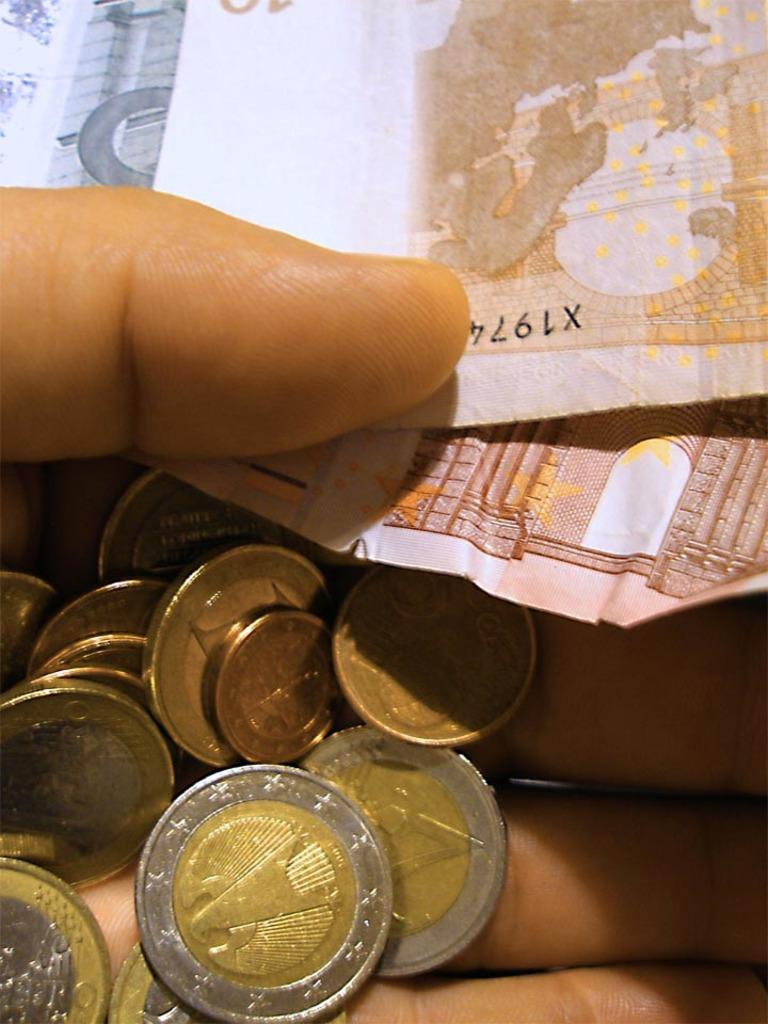<image>
Provide a brief description of the given image. A person is holding Euro coins and several Euro bills, one of which has a serial number starting with X1974. 